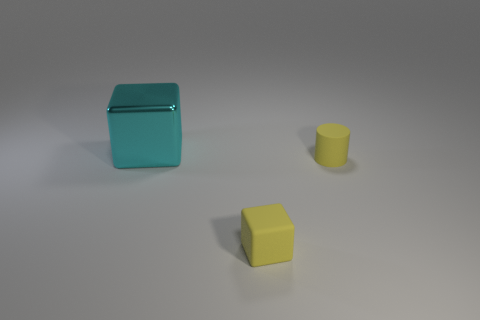Subtract all green cubes. Subtract all cyan cylinders. How many cubes are left? 2 Add 3 big rubber cylinders. How many objects exist? 6 Subtract all cubes. How many objects are left? 1 Add 2 big cyan cubes. How many big cyan cubes are left? 3 Add 3 cyan metallic blocks. How many cyan metallic blocks exist? 4 Subtract 0 blue cylinders. How many objects are left? 3 Subtract all big cyan shiny blocks. Subtract all small yellow things. How many objects are left? 0 